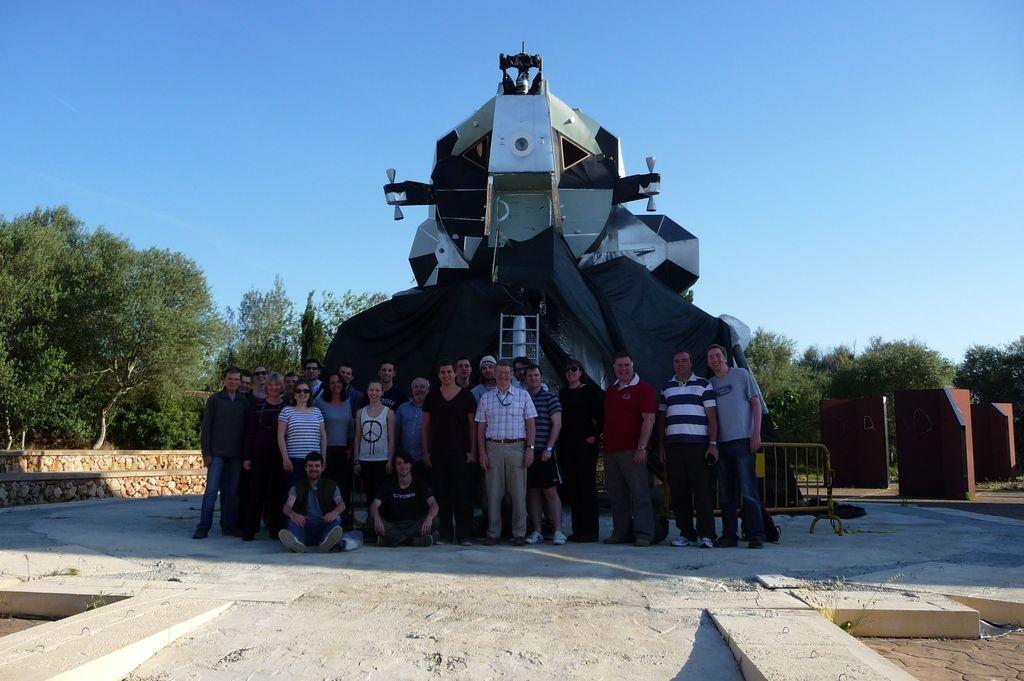Please provide a concise description of this image. This image consists of many people. In the background, it looks like a plane. At the bottom, there is a floor. In the background, there are trees. At the top, there is sky. 